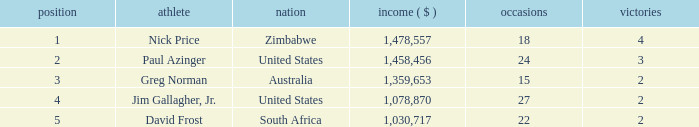In south africa, how many events are occurring? 22.0. 